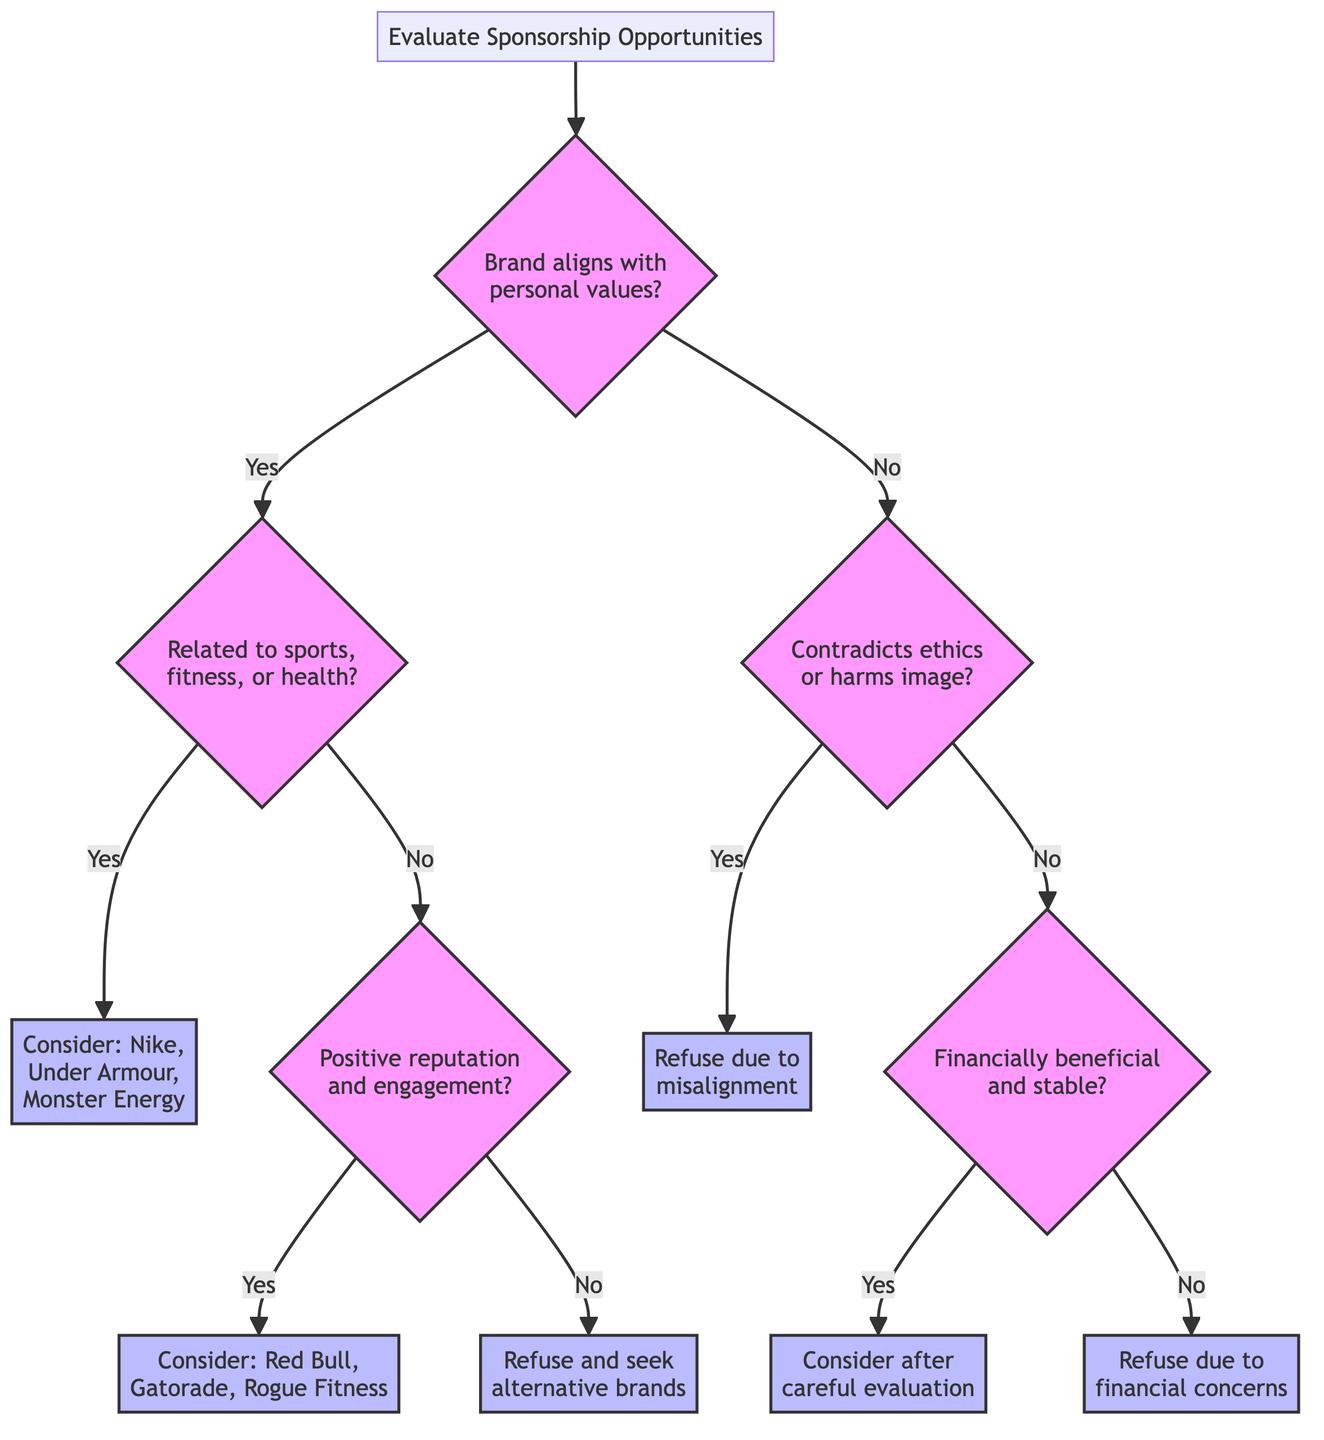What is the root of the decision tree? The root of the decision tree is the starting point of the evaluation process, which is "Evaluate Sponsorship Opportunities."
Answer: Evaluate Sponsorship Opportunities How many nodes are in the decision tree? The diagram shows a total of 11 nodes, including the root and ending actions.
Answer: 11 What is the action associated with node 3? Node 3 is where the decision leads to considering sponsorship options, specifically recommending brands like Nike, Under Armour, or Monster Energy.
Answer: Consider sponsorship from brands like Nike, Under Armour, or Monster Energy What happens if the brand does not align with personal values? If the brand does not align with personal values, the next question posed is whether working with the brand contradicts personal ethics or harms the image.
Answer: Would working with this brand contradict my personal ethics or harm my image? What is the path if a brand is related to the sports, fitness, or health industry and has a positive reputation? Following from the root, if the brand aligns with personal values (yes) and is related to sports, fitness, or health (yes), the next step is to evaluate the reputation and engagement. Since it is positive, the action leads to considering brands like Red Bull, Gatorade, or Rogue Fitness.
Answer: Consider sponsorship from brands like Red Bull, Gatorade, or Rogue Fitness What is the final action if the potential sponsorship is financially beneficial? If the brand does not contradict personal values and the sponsorship is financially beneficial, the next action is to carefully evaluate the sponsorship from financially stable brands.
Answer: Consider sponsorship from financially stable brands after careful evaluation What must happen for the sponsorship to be refused for financial concerns? Refusing sponsorship due to financial concerns occurs if the potential sponsorship is not financially beneficial or stable after evaluation.
Answer: Refuse sponsorship due to financial concerns If a brand contradicts personal values, what is the action taken? If a brand contradicts personal values, the action taken is to refuse sponsorship due to the misalignment with personal values.
Answer: Refuse sponsorship due to misalignment with personal values What brands are suggested for consideration if a brand is related to sports but does not have a positive reputation? If the brand is related to sports but does not have a positive reputation, the diagram indicates to refuse sponsorship and seek alternative brands.
Answer: Refuse sponsorship and look for alternative brands that better align with my values 